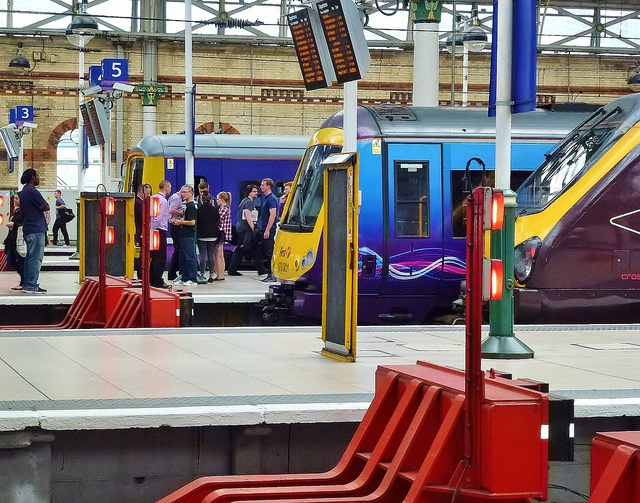Describe the objects in this image and their specific colors. I can see train in white, black, navy, lightblue, and gray tones, train in white, black, purple, and gray tones, train in white, darkblue, lightblue, and navy tones, people in white, black, navy, blue, and gray tones, and people in white, black, navy, darkgray, and gray tones in this image. 